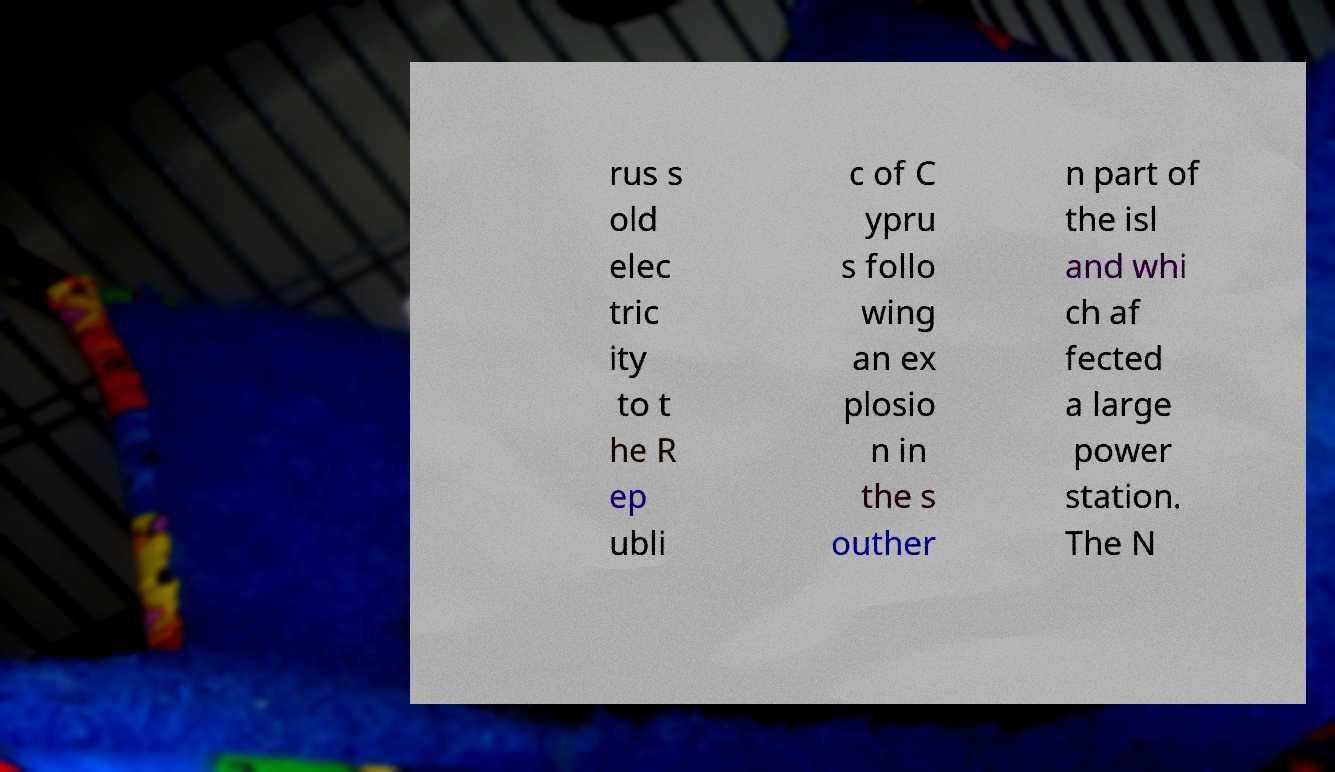Could you extract and type out the text from this image? rus s old elec tric ity to t he R ep ubli c of C ypru s follo wing an ex plosio n in the s outher n part of the isl and whi ch af fected a large power station. The N 